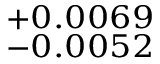Convert formula to latex. <formula><loc_0><loc_0><loc_500><loc_500>^ { + 0 . 0 0 6 9 } _ { - 0 . 0 0 5 2 }</formula> 